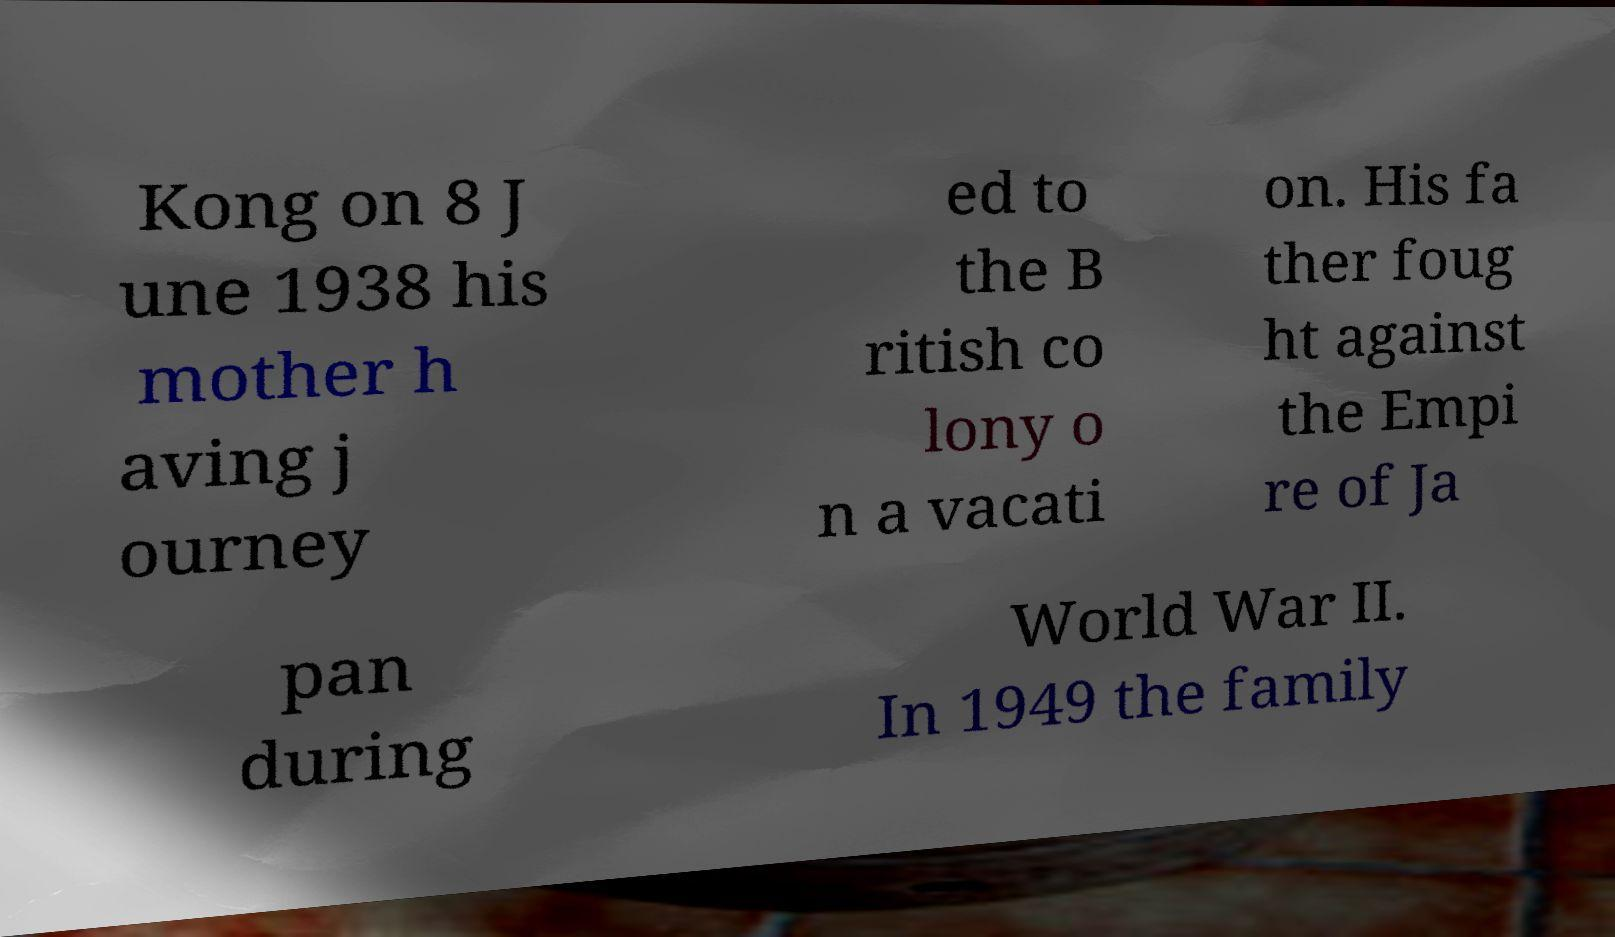Could you extract and type out the text from this image? Kong on 8 J une 1938 his mother h aving j ourney ed to the B ritish co lony o n a vacati on. His fa ther foug ht against the Empi re of Ja pan during World War II. In 1949 the family 